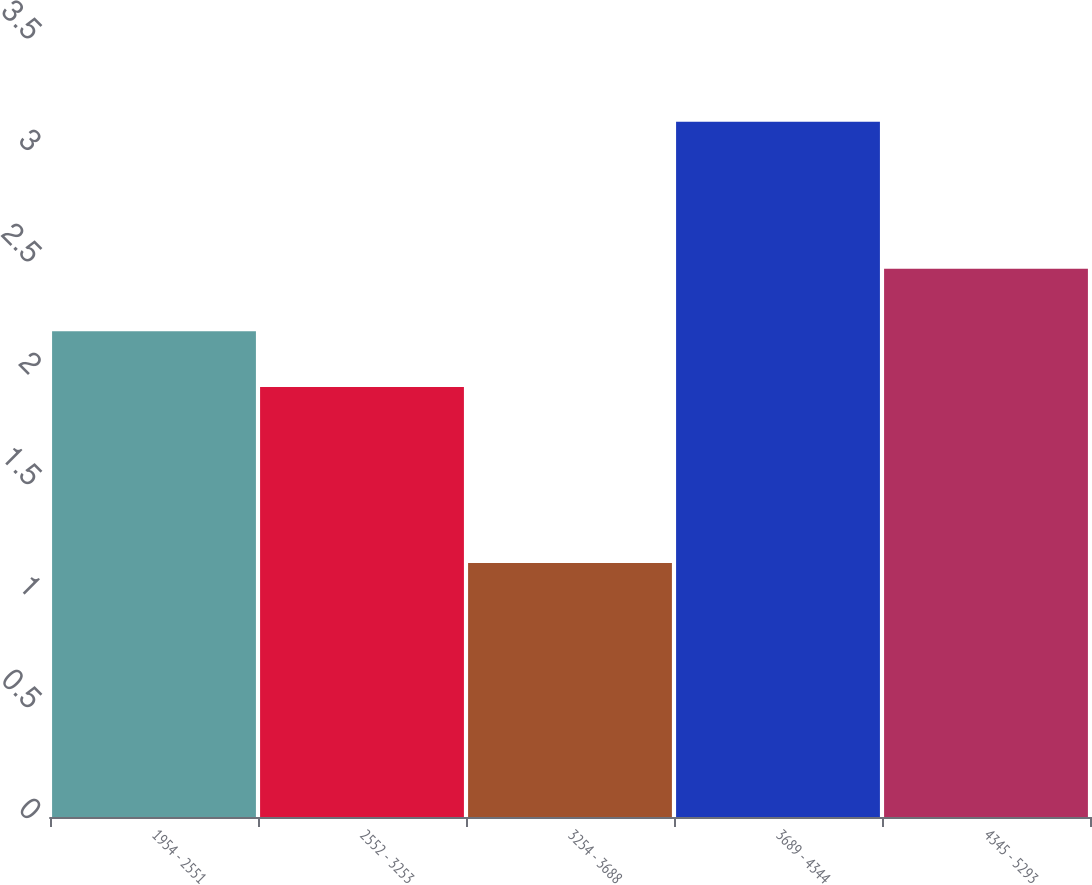Convert chart. <chart><loc_0><loc_0><loc_500><loc_500><bar_chart><fcel>1954 - 2551<fcel>2552 - 3253<fcel>3254 - 3688<fcel>3689 - 4344<fcel>4345 - 5293<nl><fcel>2.18<fcel>1.93<fcel>1.14<fcel>3.12<fcel>2.46<nl></chart> 